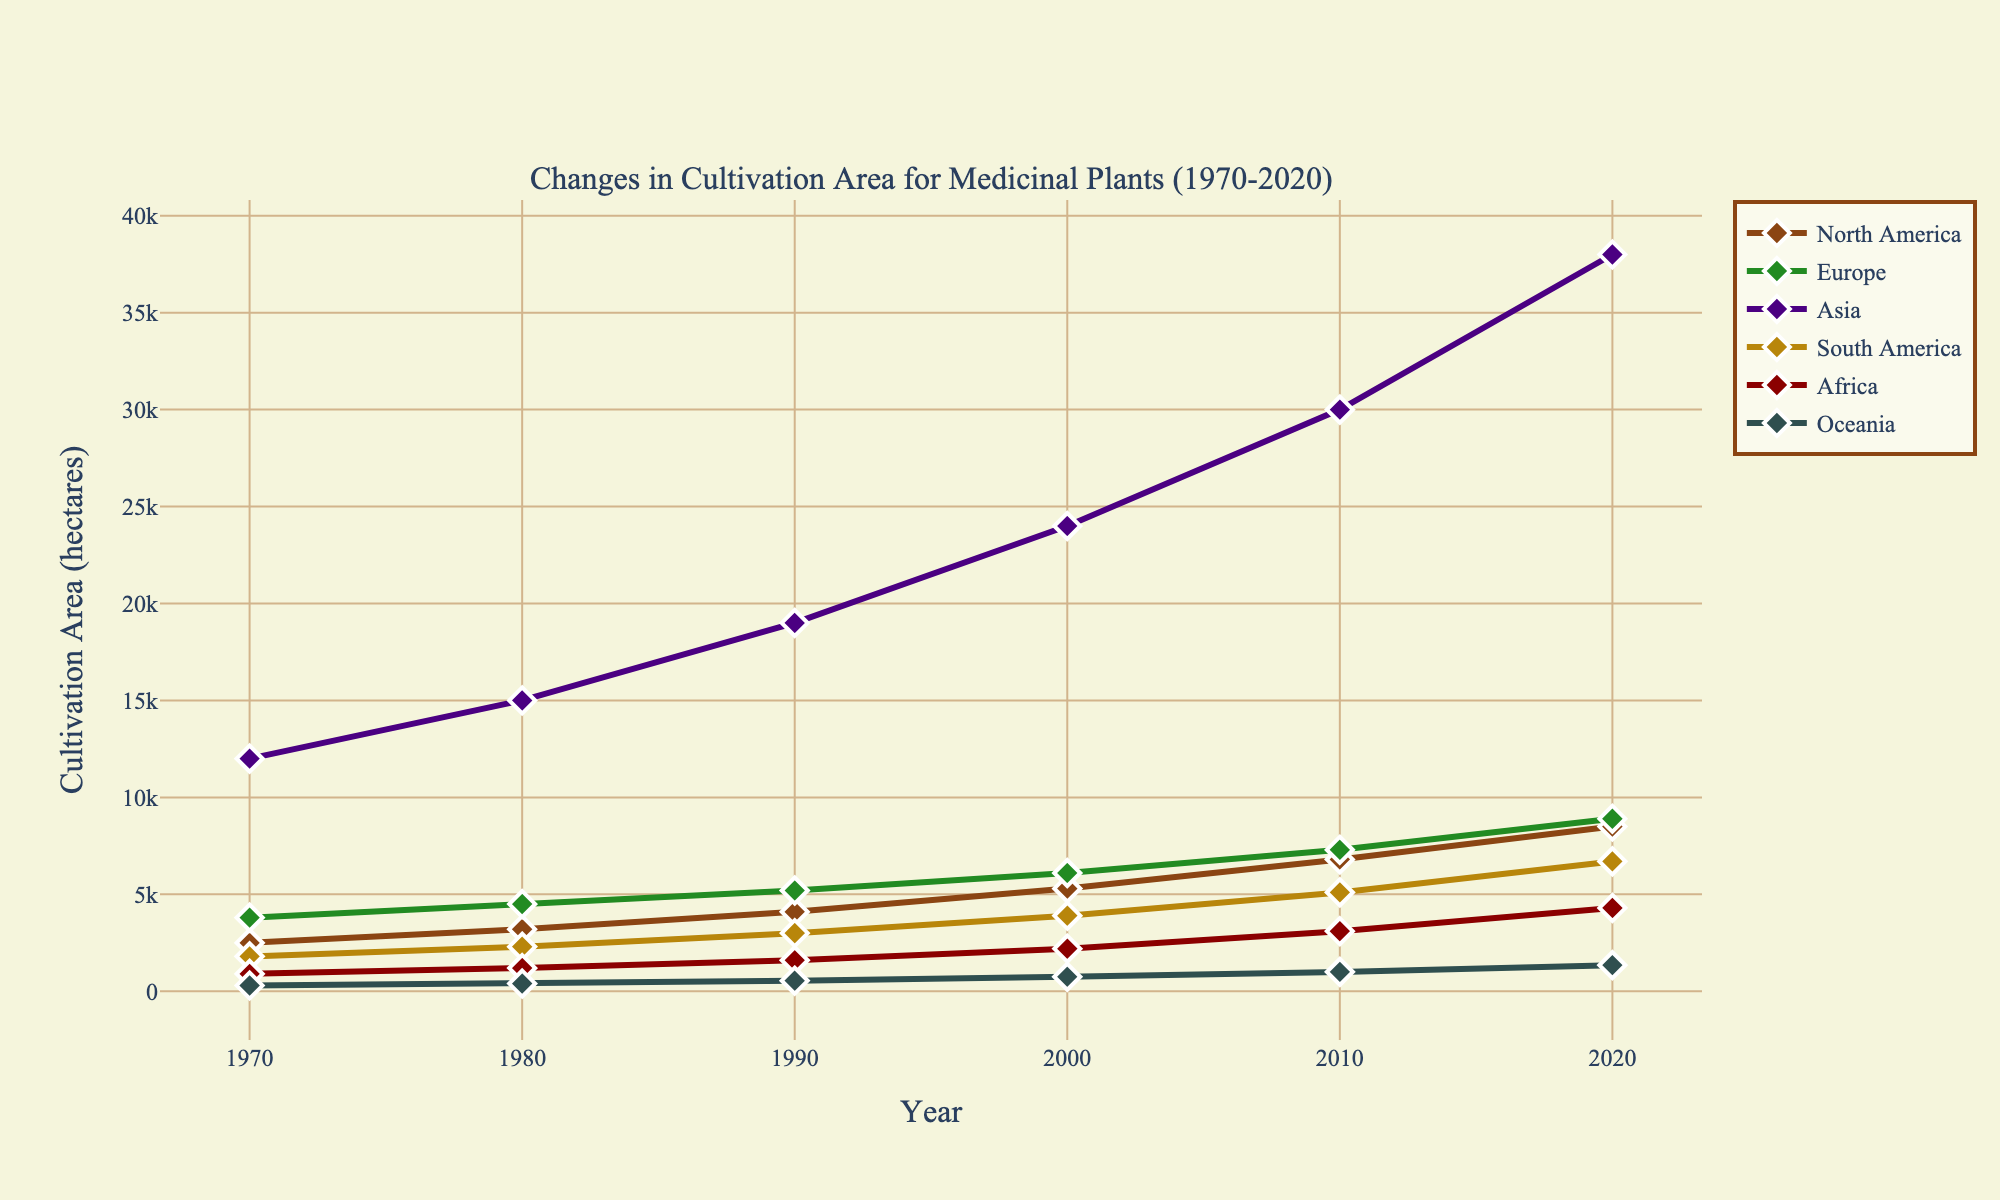What's the total cultivation area in North America and Europe in 2020? The cultivation area in 2020 for North America is 8500 hectares and for Europe, it is 8900 hectares. Adding these together gives 8500 + 8900 = 17400 hectares.
Answer: 17400 hectares Which region has the highest cultivation area in 2020? From the figure, Asia has the highest cultivation area in 2020 with 38000 hectares.
Answer: Asia What is the change in cultivation area in South America from 1970 to 2020? In 1970, the cultivation area in South America was 1800 hectares and in 2020, it was 6700 hectares. The change is 6700 - 1800 = 4900 hectares.
Answer: 4900 hectares Between 2010 and 2020, which region experienced the biggest increase in cultivation area? Asia experienced the biggest increase with an increase of 38000 - 30000 = 8000 hectares.
Answer: Asia Among Africa, Oceania, and Europe, which region had the least cultivation area in 1990? In 1990, Africa had 1600 hectares, Oceania had 550 hectares, and Europe had 5200 hectares. Oceania had the least cultivation area with 550 hectares.
Answer: Oceania By how much did the cultivation area in North America grow from 1970 to 1990? In 1970, the cultivation area in North America was 2500 hectares, and in 1990, it grew to 4100 hectares. The growth is 4100 - 2500 = 1600 hectares.
Answer: 1600 hectares Which region showed the smallest increase in cultivation area from 2010 to 2020? Oceania showed the smallest increase with an increase from 1000 hectares in 2010 to 1350 hectares in 2020, which is an increase of 1350 - 1000 = 350 hectares.
Answer: Oceania What is the average cultivation area in Europe over the 50-year period? Over the years 1970 to 2020, Europe has areas 3800, 4500, 5200, 6100, 7300, and 8900 hectares. The average is calculated as (3800 + 4500 + 5200 + 6100 + 7300 + 8900) / 6 = 5133.33 hectares.
Answer: 5133.33 hectares During which decade did Africa see the most significant increase in cultivation area? From 1970 to 1980, Africa's area increased by 1200 - 900 = 300 hectares; from 1980 to 1990, it increased by 1600 - 1200 = 400 hectares; from 1990 to 2000, it increased by 2200 - 1600 = 600 hectares; from 2000 to 2010, it increased by 3100 - 2200 = 900 hectares; and from 2010 to 2020, it increased by 4300 - 3100 = 1200 hectares. The most significant increase was from 2010 to 2020 (1200 hectares).
Answer: 2010 to 2020 